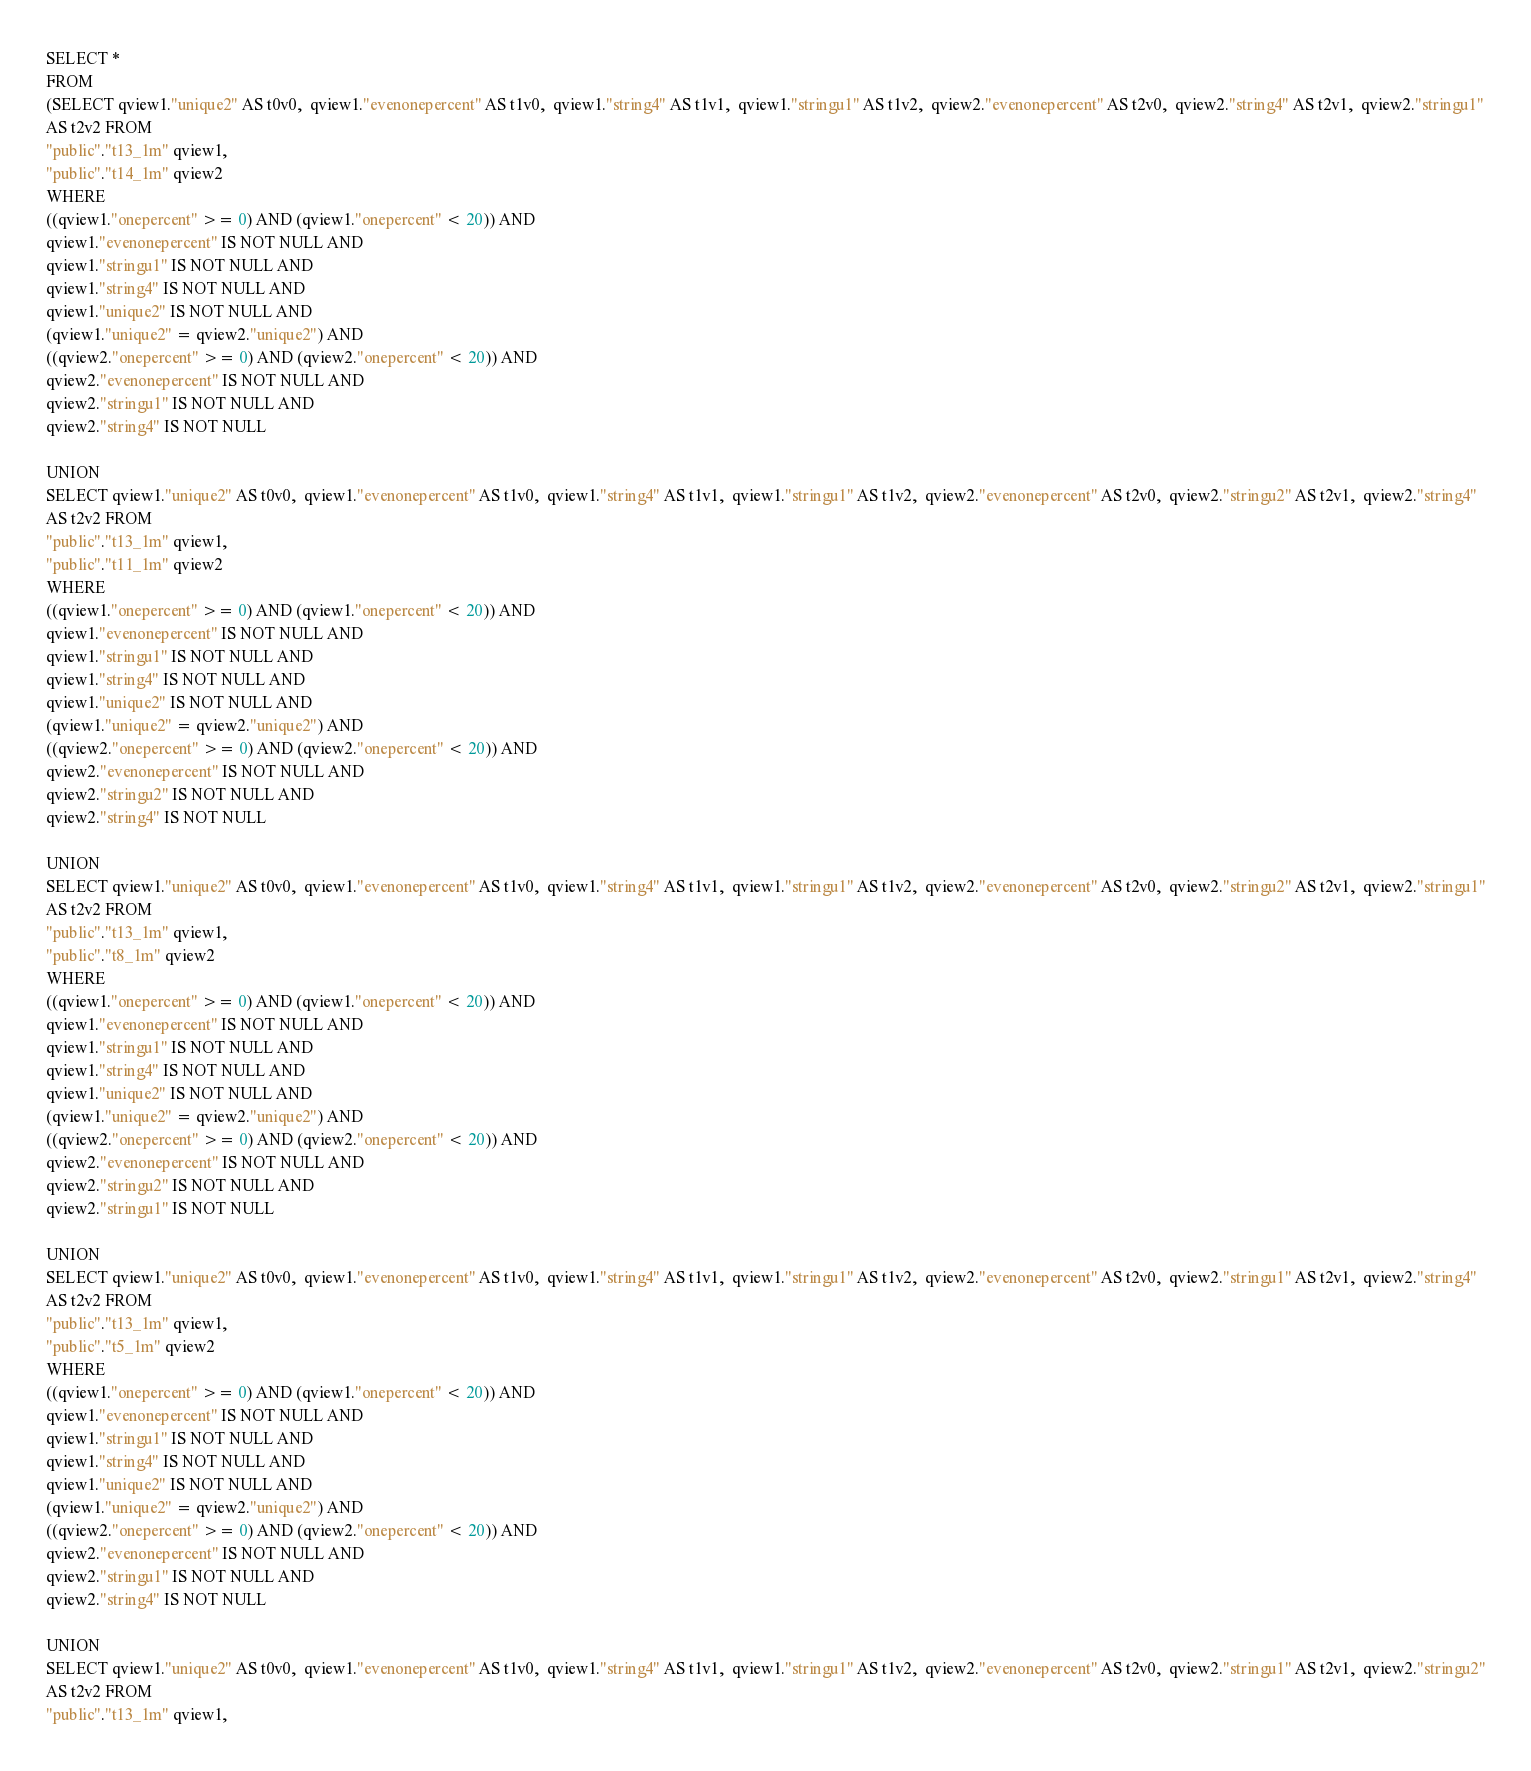<code> <loc_0><loc_0><loc_500><loc_500><_SQL_>SELECT *
FROM
(SELECT qview1."unique2" AS t0v0,  qview1."evenonepercent" AS t1v0,  qview1."string4" AS t1v1,  qview1."stringu1" AS t1v2,  qview2."evenonepercent" AS t2v0,  qview2."string4" AS t2v1,  qview2."stringu1"
AS t2v2 FROM
"public"."t13_1m" qview1,
"public"."t14_1m" qview2
WHERE
((qview1."onepercent" >= 0) AND (qview1."onepercent" < 20)) AND
qview1."evenonepercent" IS NOT NULL AND
qview1."stringu1" IS NOT NULL AND
qview1."string4" IS NOT NULL AND
qview1."unique2" IS NOT NULL AND
(qview1."unique2" = qview2."unique2") AND
((qview2."onepercent" >= 0) AND (qview2."onepercent" < 20)) AND
qview2."evenonepercent" IS NOT NULL AND
qview2."stringu1" IS NOT NULL AND
qview2."string4" IS NOT NULL

UNION
SELECT qview1."unique2" AS t0v0,  qview1."evenonepercent" AS t1v0,  qview1."string4" AS t1v1,  qview1."stringu1" AS t1v2,  qview2."evenonepercent" AS t2v0,  qview2."stringu2" AS t2v1,  qview2."string4"
AS t2v2 FROM
"public"."t13_1m" qview1,
"public"."t11_1m" qview2
WHERE
((qview1."onepercent" >= 0) AND (qview1."onepercent" < 20)) AND
qview1."evenonepercent" IS NOT NULL AND
qview1."stringu1" IS NOT NULL AND
qview1."string4" IS NOT NULL AND
qview1."unique2" IS NOT NULL AND
(qview1."unique2" = qview2."unique2") AND
((qview2."onepercent" >= 0) AND (qview2."onepercent" < 20)) AND
qview2."evenonepercent" IS NOT NULL AND
qview2."stringu2" IS NOT NULL AND
qview2."string4" IS NOT NULL

UNION
SELECT qview1."unique2" AS t0v0,  qview1."evenonepercent" AS t1v0,  qview1."string4" AS t1v1,  qview1."stringu1" AS t1v2,  qview2."evenonepercent" AS t2v0,  qview2."stringu2" AS t2v1,  qview2."stringu1"
AS t2v2 FROM
"public"."t13_1m" qview1,
"public"."t8_1m" qview2
WHERE
((qview1."onepercent" >= 0) AND (qview1."onepercent" < 20)) AND
qview1."evenonepercent" IS NOT NULL AND
qview1."stringu1" IS NOT NULL AND
qview1."string4" IS NOT NULL AND
qview1."unique2" IS NOT NULL AND
(qview1."unique2" = qview2."unique2") AND
((qview2."onepercent" >= 0) AND (qview2."onepercent" < 20)) AND
qview2."evenonepercent" IS NOT NULL AND
qview2."stringu2" IS NOT NULL AND
qview2."stringu1" IS NOT NULL

UNION
SELECT qview1."unique2" AS t0v0,  qview1."evenonepercent" AS t1v0,  qview1."string4" AS t1v1,  qview1."stringu1" AS t1v2,  qview2."evenonepercent" AS t2v0,  qview2."stringu1" AS t2v1,  qview2."string4"
AS t2v2 FROM
"public"."t13_1m" qview1,
"public"."t5_1m" qview2
WHERE
((qview1."onepercent" >= 0) AND (qview1."onepercent" < 20)) AND
qview1."evenonepercent" IS NOT NULL AND
qview1."stringu1" IS NOT NULL AND
qview1."string4" IS NOT NULL AND
qview1."unique2" IS NOT NULL AND
(qview1."unique2" = qview2."unique2") AND
((qview2."onepercent" >= 0) AND (qview2."onepercent" < 20)) AND
qview2."evenonepercent" IS NOT NULL AND
qview2."stringu1" IS NOT NULL AND
qview2."string4" IS NOT NULL

UNION
SELECT qview1."unique2" AS t0v0,  qview1."evenonepercent" AS t1v0,  qview1."string4" AS t1v1,  qview1."stringu1" AS t1v2,  qview2."evenonepercent" AS t2v0,  qview2."stringu1" AS t2v1,  qview2."stringu2"
AS t2v2 FROM
"public"."t13_1m" qview1,</code> 